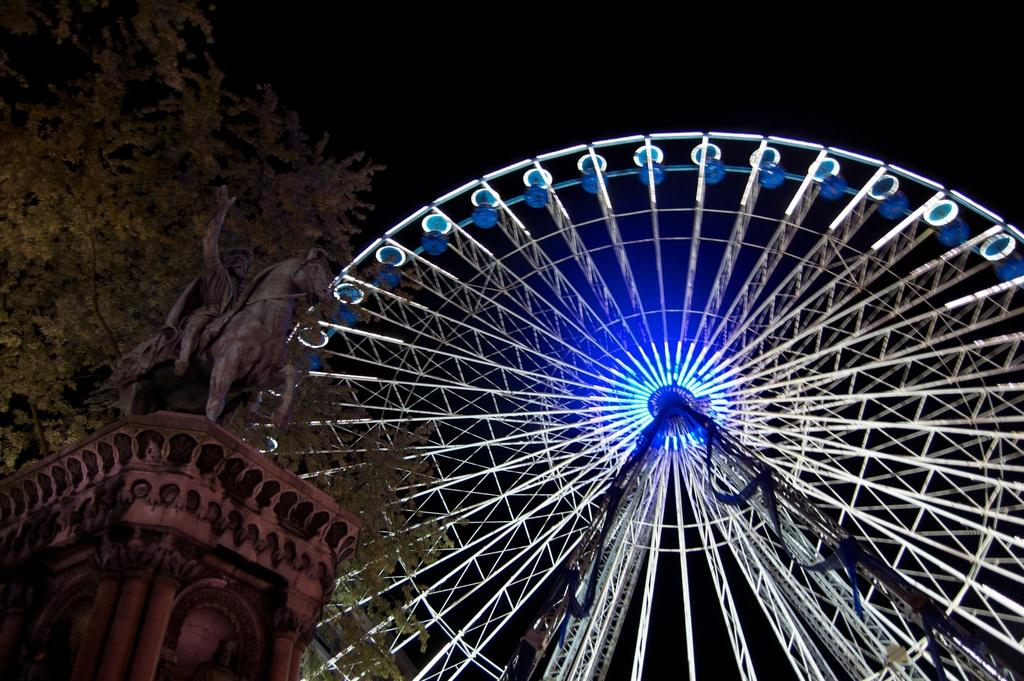What is the main subject in the image? There is a sculpture in the image. What other large object can be seen in the image? There is a giant wheel in the image. Where is the tree located in the image? The tree is on the left side of the image. What type of arm is holding the sculpture in the image? There is no arm present in the image; the sculpture is stationary. What scientific theory is being demonstrated by the sculpture in the image? The image does not depict a scientific theory; it simply shows a sculpture and a giant wheel. 